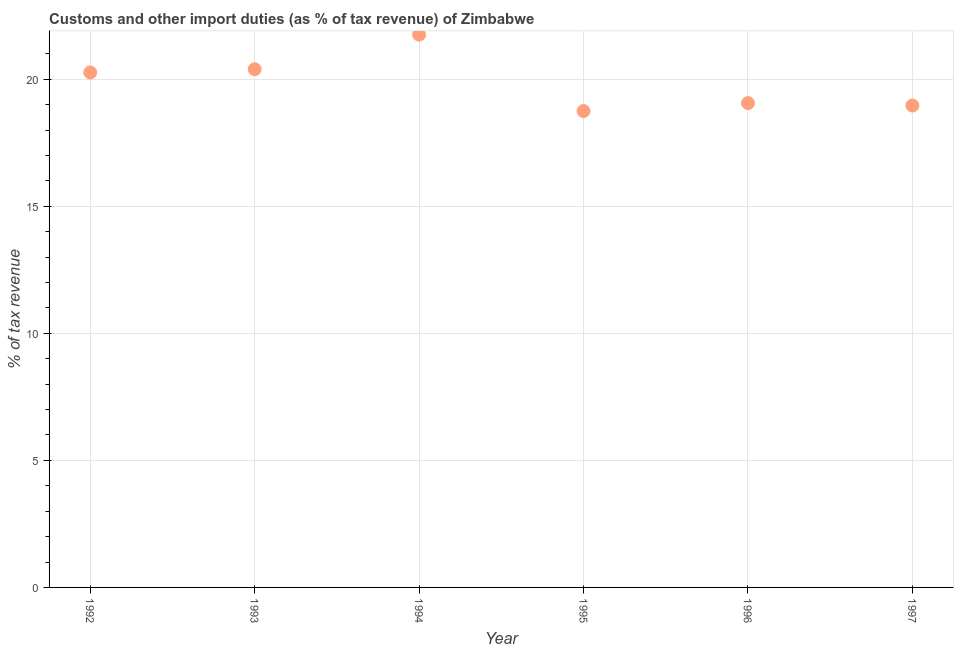What is the customs and other import duties in 1995?
Offer a very short reply. 18.75. Across all years, what is the maximum customs and other import duties?
Offer a terse response. 21.76. Across all years, what is the minimum customs and other import duties?
Provide a short and direct response. 18.75. In which year was the customs and other import duties minimum?
Provide a succinct answer. 1995. What is the sum of the customs and other import duties?
Offer a very short reply. 119.21. What is the difference between the customs and other import duties in 1996 and 1997?
Provide a succinct answer. 0.1. What is the average customs and other import duties per year?
Offer a very short reply. 19.87. What is the median customs and other import duties?
Your response must be concise. 19.67. Do a majority of the years between 1992 and 1993 (inclusive) have customs and other import duties greater than 10 %?
Offer a terse response. Yes. What is the ratio of the customs and other import duties in 1995 to that in 1996?
Your answer should be compact. 0.98. Is the customs and other import duties in 1995 less than that in 1997?
Keep it short and to the point. Yes. What is the difference between the highest and the second highest customs and other import duties?
Make the answer very short. 1.36. Is the sum of the customs and other import duties in 1995 and 1996 greater than the maximum customs and other import duties across all years?
Provide a succinct answer. Yes. What is the difference between the highest and the lowest customs and other import duties?
Make the answer very short. 3.01. Does the customs and other import duties monotonically increase over the years?
Keep it short and to the point. No. What is the difference between two consecutive major ticks on the Y-axis?
Keep it short and to the point. 5. Does the graph contain any zero values?
Ensure brevity in your answer.  No. What is the title of the graph?
Your response must be concise. Customs and other import duties (as % of tax revenue) of Zimbabwe. What is the label or title of the Y-axis?
Make the answer very short. % of tax revenue. What is the % of tax revenue in 1992?
Provide a short and direct response. 20.27. What is the % of tax revenue in 1993?
Keep it short and to the point. 20.4. What is the % of tax revenue in 1994?
Offer a terse response. 21.76. What is the % of tax revenue in 1995?
Give a very brief answer. 18.75. What is the % of tax revenue in 1996?
Provide a succinct answer. 19.06. What is the % of tax revenue in 1997?
Provide a succinct answer. 18.97. What is the difference between the % of tax revenue in 1992 and 1993?
Make the answer very short. -0.13. What is the difference between the % of tax revenue in 1992 and 1994?
Offer a terse response. -1.49. What is the difference between the % of tax revenue in 1992 and 1995?
Give a very brief answer. 1.52. What is the difference between the % of tax revenue in 1992 and 1996?
Make the answer very short. 1.2. What is the difference between the % of tax revenue in 1992 and 1997?
Provide a short and direct response. 1.3. What is the difference between the % of tax revenue in 1993 and 1994?
Your answer should be compact. -1.36. What is the difference between the % of tax revenue in 1993 and 1995?
Your answer should be very brief. 1.65. What is the difference between the % of tax revenue in 1993 and 1996?
Keep it short and to the point. 1.33. What is the difference between the % of tax revenue in 1993 and 1997?
Offer a very short reply. 1.43. What is the difference between the % of tax revenue in 1994 and 1995?
Offer a terse response. 3.01. What is the difference between the % of tax revenue in 1994 and 1996?
Make the answer very short. 2.69. What is the difference between the % of tax revenue in 1994 and 1997?
Provide a succinct answer. 2.79. What is the difference between the % of tax revenue in 1995 and 1996?
Offer a very short reply. -0.31. What is the difference between the % of tax revenue in 1995 and 1997?
Keep it short and to the point. -0.22. What is the difference between the % of tax revenue in 1996 and 1997?
Give a very brief answer. 0.1. What is the ratio of the % of tax revenue in 1992 to that in 1993?
Offer a terse response. 0.99. What is the ratio of the % of tax revenue in 1992 to that in 1994?
Keep it short and to the point. 0.93. What is the ratio of the % of tax revenue in 1992 to that in 1995?
Offer a very short reply. 1.08. What is the ratio of the % of tax revenue in 1992 to that in 1996?
Make the answer very short. 1.06. What is the ratio of the % of tax revenue in 1992 to that in 1997?
Offer a terse response. 1.07. What is the ratio of the % of tax revenue in 1993 to that in 1994?
Keep it short and to the point. 0.94. What is the ratio of the % of tax revenue in 1993 to that in 1995?
Provide a short and direct response. 1.09. What is the ratio of the % of tax revenue in 1993 to that in 1996?
Your answer should be compact. 1.07. What is the ratio of the % of tax revenue in 1993 to that in 1997?
Make the answer very short. 1.07. What is the ratio of the % of tax revenue in 1994 to that in 1995?
Offer a very short reply. 1.16. What is the ratio of the % of tax revenue in 1994 to that in 1996?
Your answer should be compact. 1.14. What is the ratio of the % of tax revenue in 1994 to that in 1997?
Offer a very short reply. 1.15. What is the ratio of the % of tax revenue in 1995 to that in 1996?
Give a very brief answer. 0.98. What is the ratio of the % of tax revenue in 1996 to that in 1997?
Provide a short and direct response. 1. 